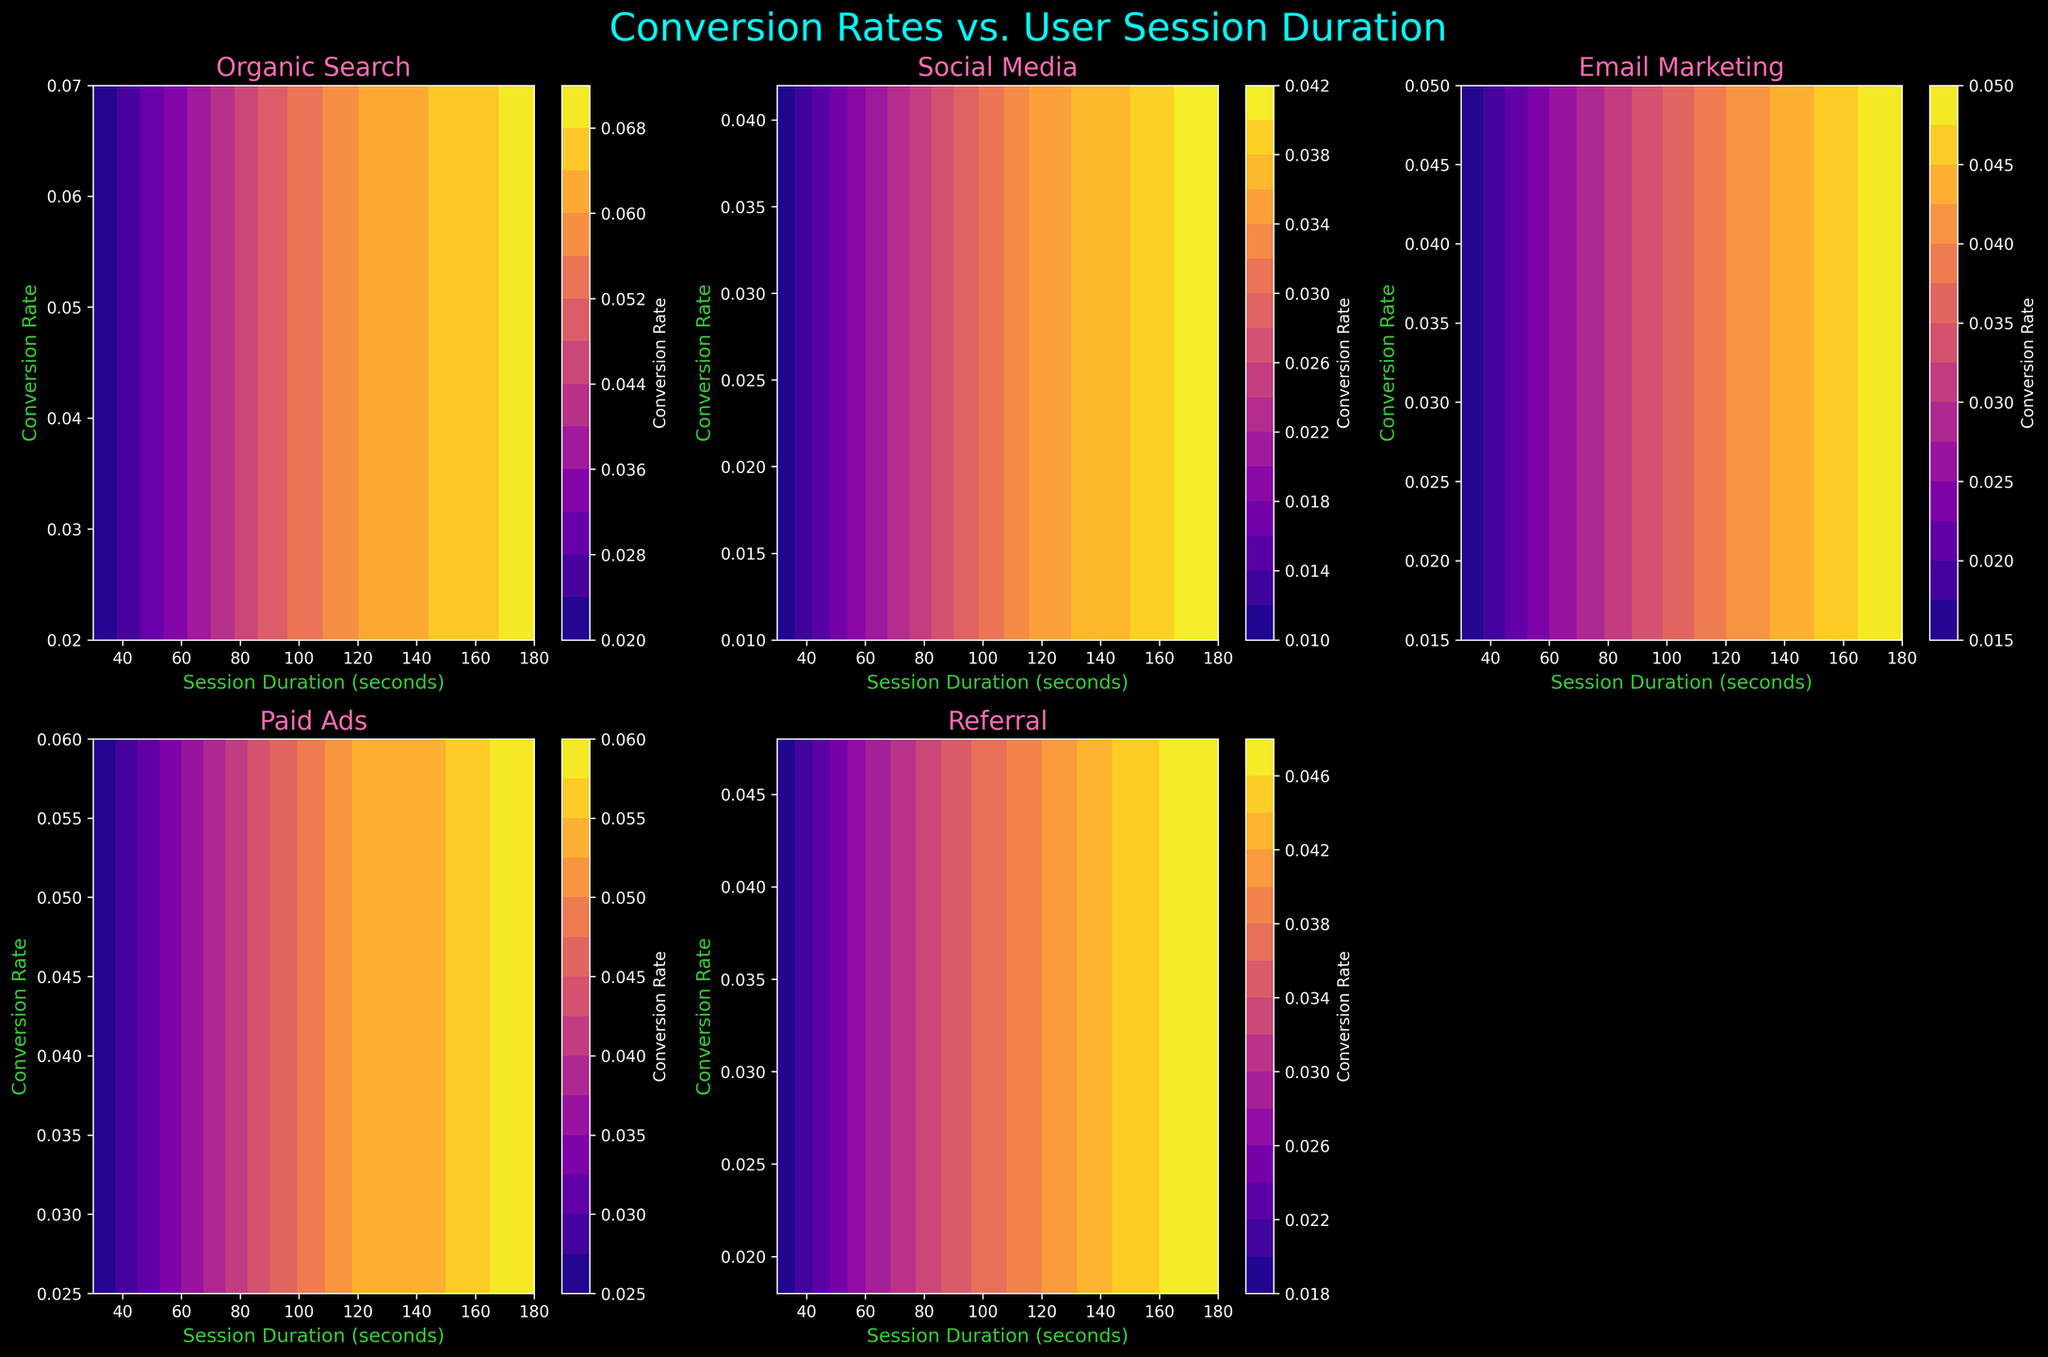What is the title of the figure? The title is displayed at the top center of the figure. It's usually larger and in bold font, making it easily noticeable.
Answer: Conversion Rates vs. User Session Duration What is the color of the labels on the x and y axes? The labels on the axes are colored for better visibility against the dark background. These colors can be easily identified by looking at the text beside the axes.
Answer: Green Which marketing channel shows the highest conversion rate for a session duration of 60 seconds? By observing the contour plots for all channels at the 60-second mark on the x-axis, you can identify the highest point on the y-axis for Conversion Rate.
Answer: Organic Search Compare the conversion rates of Email Marketing and Paid Ads at a session duration of 90 seconds. Which one is higher? For both Email Marketing and Paid Ads, find the corresponding conversion rate at a 90-second session duration. Then, compare these values to see which is higher.
Answer: Paid Ads Which marketing channel has the steepest increase in conversion rate as session duration increases? Examine the contour lines and gradients for all channels. The channel with the steepest curves and most closely packed lines indicates the fastest rate of increase.
Answer: Organic Search What is the range of session durations displayed on the x-axis? The x-axis covers the session duration in seconds. Observing the minimum and maximum ticks on this axis gives the range.
Answer: 30 to 180 seconds Which subplot indicates the lowest initial conversion rate at a 30-second session duration? Check the conversion rates at the point where the x-axis is 30 seconds for each subplot. Identify the one with the lowest initial conversion rate.
Answer: Social Media At what session duration do we see the last non-empty subplot for Referral marketing? The last non-empty subplot will have the highest session duration before the axis is turned off. By checking the session duration values against the tick marks in the Referral subplot, you can find this duration.
Answer: 180 seconds Is the color bar shared among all subplots or individual to each subplot? Observe if there is a single color bar for all subplots or if each subplot has its own. The figure usually positions these bars accordingly.
Answer: Individual to each subplot 